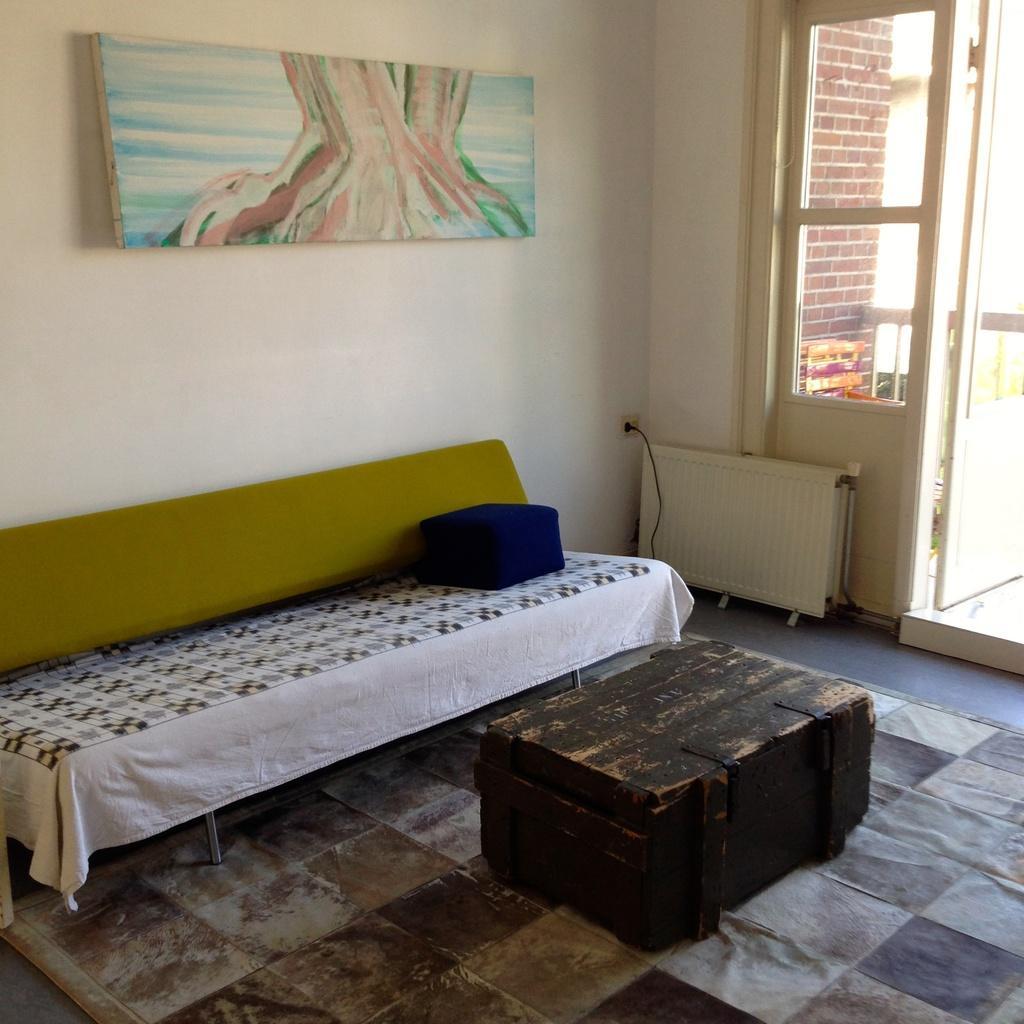How would you summarize this image in a sentence or two? in a room there is a bed, box. behind there is a wall on which there is a photo frame. a the right there is a door. 